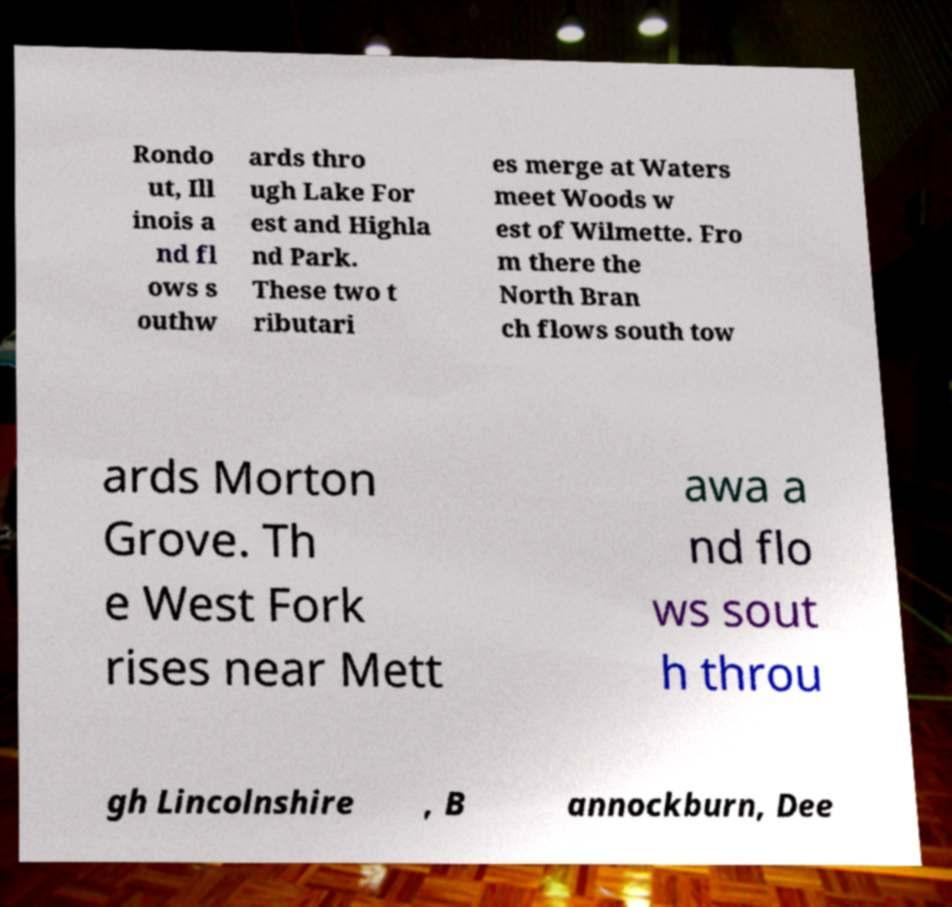Please read and relay the text visible in this image. What does it say? Rondo ut, Ill inois a nd fl ows s outhw ards thro ugh Lake For est and Highla nd Park. These two t ributari es merge at Waters meet Woods w est of Wilmette. Fro m there the North Bran ch flows south tow ards Morton Grove. Th e West Fork rises near Mett awa a nd flo ws sout h throu gh Lincolnshire , B annockburn, Dee 